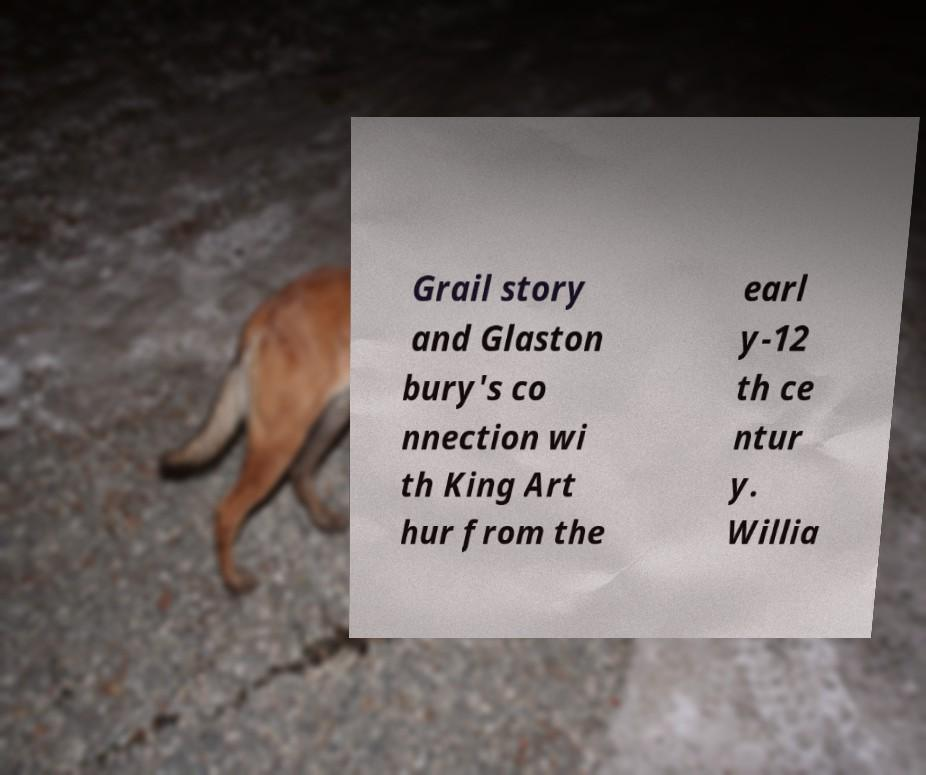Could you assist in decoding the text presented in this image and type it out clearly? Grail story and Glaston bury's co nnection wi th King Art hur from the earl y-12 th ce ntur y. Willia 